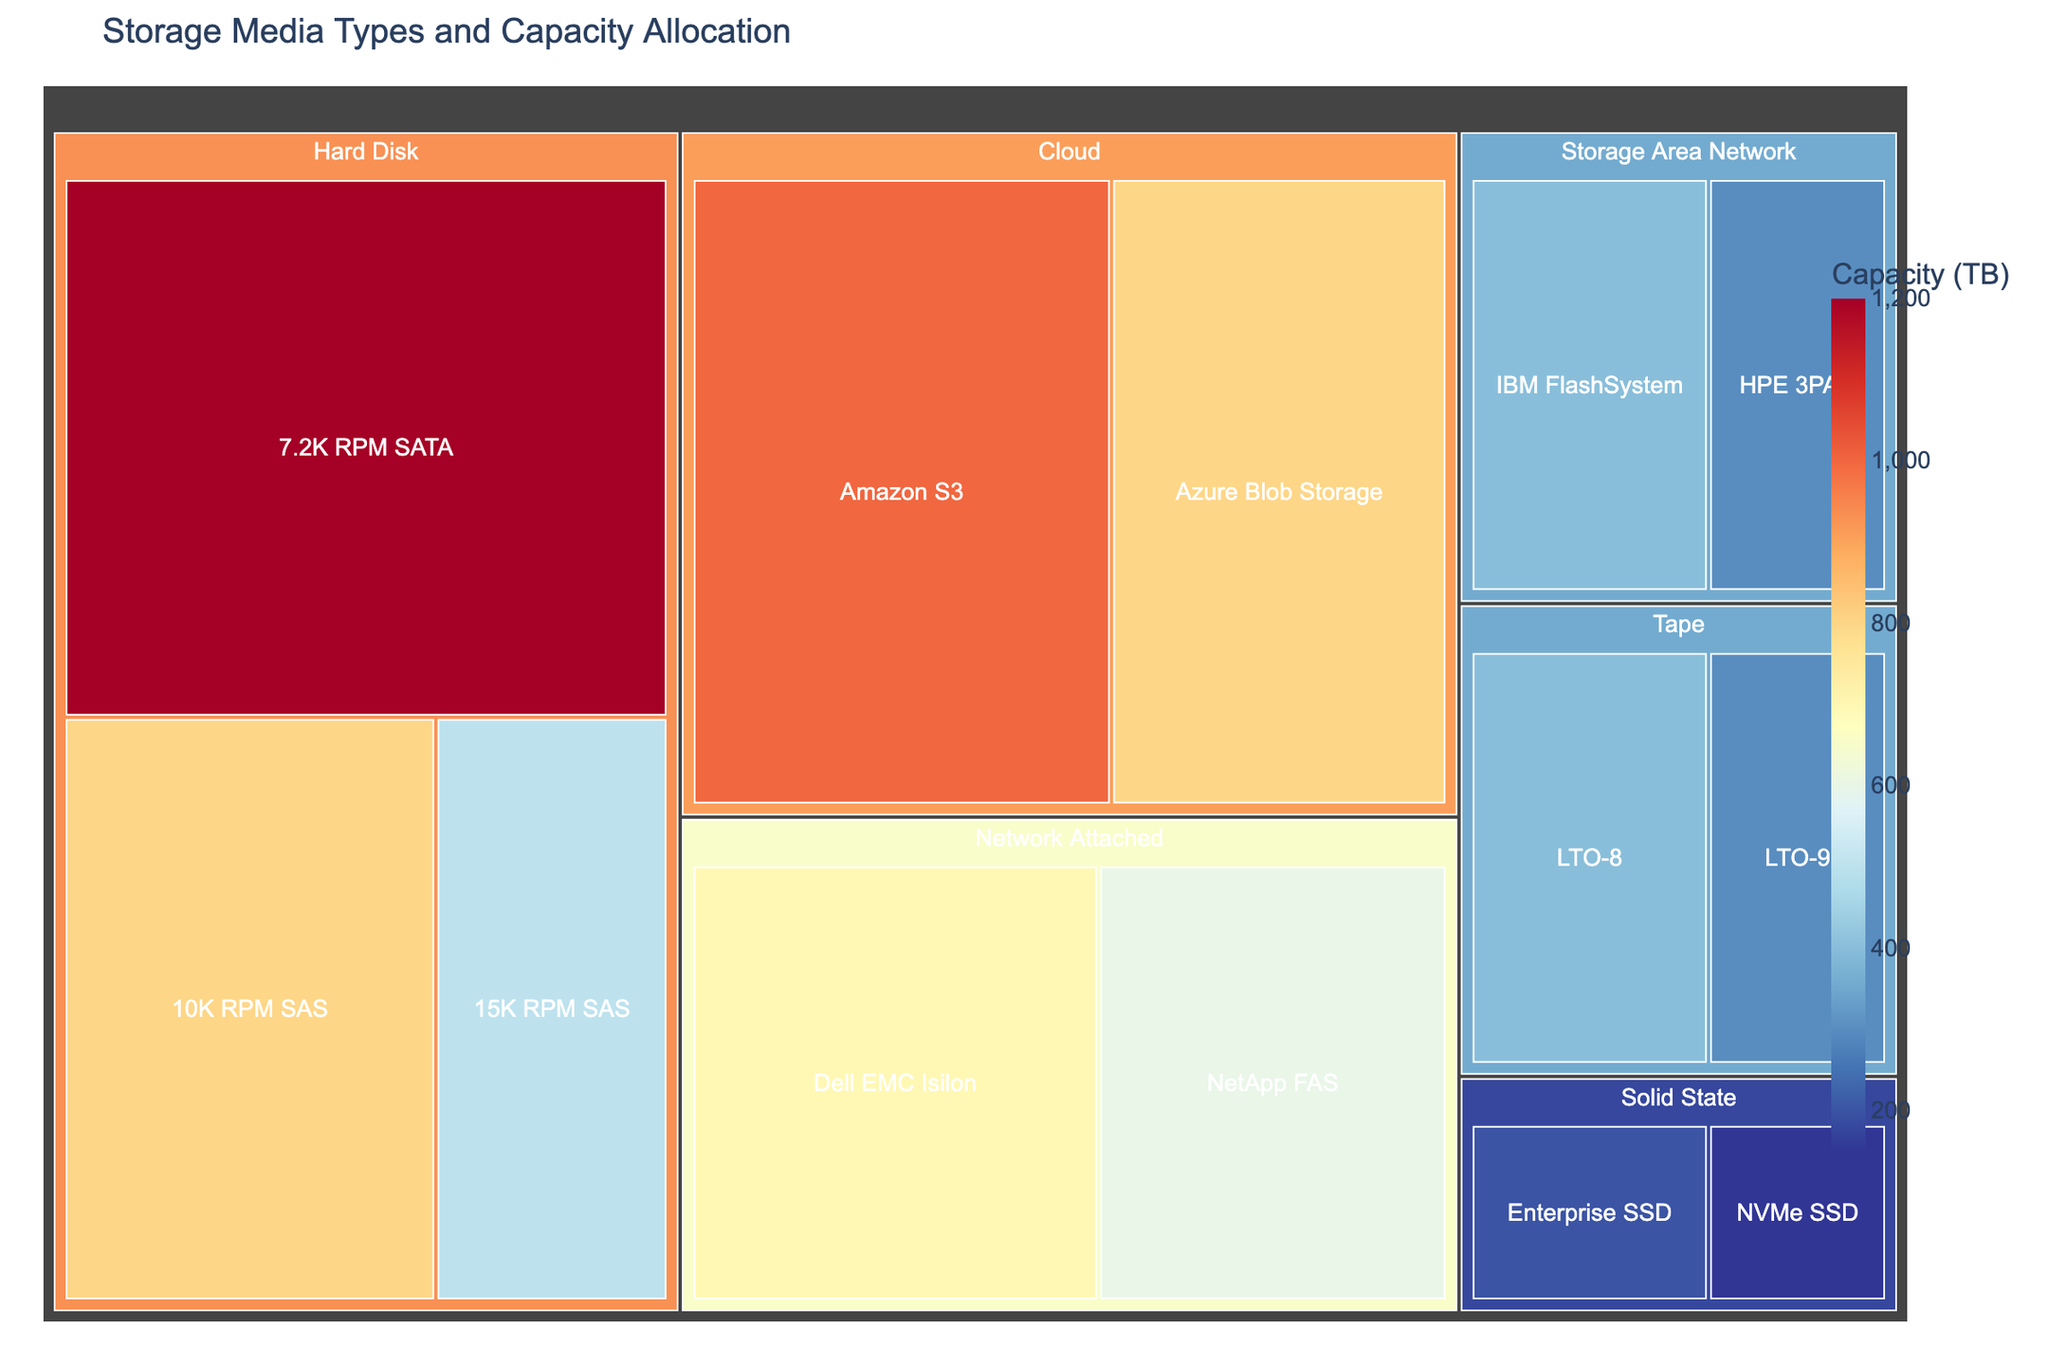What's the title of the treemap? The title is usually found at the top of the figure. In this case, you can see the text at the top of the treemap that states its purpose.
Answer: Storage Media Types and Capacity Allocation Which storage type has the highest total capacity? To determine the highest capacity, sum the capacities of each media type within each storage type. Compare the sums to find which is largest. For Hard Disk: 500 + 800 + 1200 = 2500 TB, Solid State: 200 + 150 = 350 TB, Tape: 400 + 300 = 700 TB, Cloud: 1000 + 800 = 1800 TB, Network Attached: 600 + 700 = 1300 TB, Storage Area Network: 400 + 300 = 700 TB. The Hard Disk has the highest total capacity.
Answer: Hard Disk What is the capacity of the largest media type within the Network Attached storage type? Look at the Network Attached storage type section of the treemap and compare the capacities of NetApp FAS and Dell EMC Isilon. NetApp FAS has 600 TB and Dell EMC Isilon has 700 TB.
Answer: 700 TB How many unique storage types are displayed on the treemap? Count the number of top-level categories in the treemap, each representing a unique storage type. The categories are Solid State, Hard Disk, Tape, Cloud, Network Attached, and Storage Area Network.
Answer: 6 Which has a higher capacity, NVMe SSD or LTO-8? Compare the capacities directly by looking at their values within the treemap. NVMe SSD has 150 TB and LTO-8 has 400 TB.
Answer: LTO-8 What's the total capacity for Tape storage type? Sum the capacities of the media types under Tape. LTO-8 has 400 TB and LTO-9 has 300 TB. So, 400 TB + 300 TB = 700 TB.
Answer: 700 TB What is the difference in capacity between 10K RPM SAS and Azure Blob Storage? Look at the capacities directly from the treemap. 10K RPM SAS has 800 TB and Azure Blob Storage has 800 TB. Their difference is 800 - 800 = 0 TB.
Answer: 0 TB Which media type within the Solid State storage type has less capacity? Compare the capacities of Enterprise SSD and NVMe SSD within the Solid State storage type. Enterprise SSD has 200 TB, and NVMe SSD has 150 TB.
Answer: NVMe SSD Among the storage media types, which one has the largest capacity? Examine all the media types in the treemap and find the one with the largest value. 7.2K RPM SATA has the largest single capacity of 1200 TB.
Answer: 7.2K RPM SATA What percentage of total storage capacity does Amazon S3 represent? First calculate the total capacity of all storage. Sum all values: 200 + 150 + 500 + 800 + 1200 + 400 + 300 + 1000 + 800 + 600 + 700 + 400 + 300 = 7350 TB. The capacity of Amazon S3 is 1000 TB. The percentage is (1000 / 7350) * 100% ≈ 13.6%.
Answer: 13.6% 